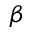<formula> <loc_0><loc_0><loc_500><loc_500>\beta</formula> 